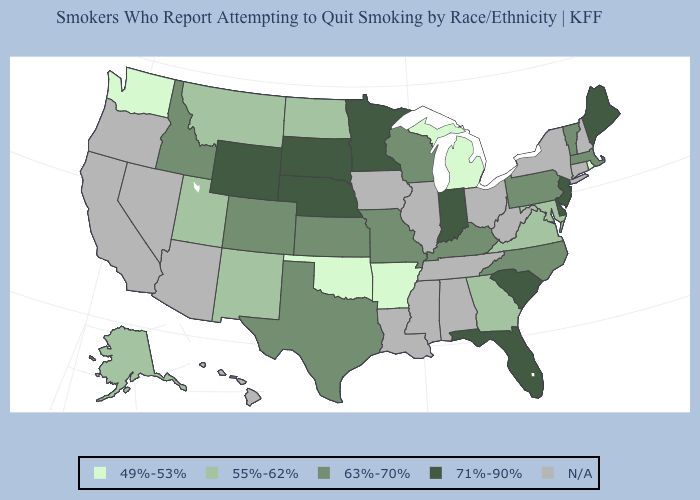What is the value of Montana?
Be succinct. 55%-62%. Does the map have missing data?
Give a very brief answer. Yes. Among the states that border West Virginia , does Maryland have the lowest value?
Be succinct. Yes. What is the highest value in states that border Oklahoma?
Keep it brief. 63%-70%. Among the states that border Illinois , which have the lowest value?
Short answer required. Kentucky, Missouri, Wisconsin. What is the highest value in the West ?
Short answer required. 71%-90%. What is the value of Tennessee?
Be succinct. N/A. What is the value of Iowa?
Short answer required. N/A. What is the lowest value in the USA?
Answer briefly. 49%-53%. Does the map have missing data?
Short answer required. Yes. Which states have the highest value in the USA?
Answer briefly. Delaware, Florida, Indiana, Maine, Minnesota, Nebraska, New Jersey, South Carolina, South Dakota, Wyoming. Name the states that have a value in the range 63%-70%?
Keep it brief. Colorado, Idaho, Kansas, Kentucky, Massachusetts, Missouri, North Carolina, Pennsylvania, Texas, Vermont, Wisconsin. What is the lowest value in the USA?
Answer briefly. 49%-53%. Does the map have missing data?
Short answer required. Yes. Among the states that border Minnesota , does North Dakota have the highest value?
Give a very brief answer. No. 